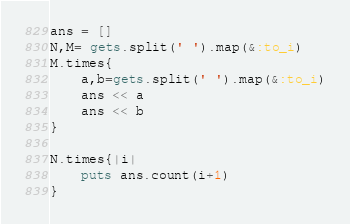<code> <loc_0><loc_0><loc_500><loc_500><_Ruby_>ans = []
N,M= gets.split(' ').map(&:to_i)
M.times{
    a,b=gets.split(' ').map(&:to_i)
    ans << a
    ans << b
}

N.times{|i|
    puts ans.count(i+1)
}</code> 